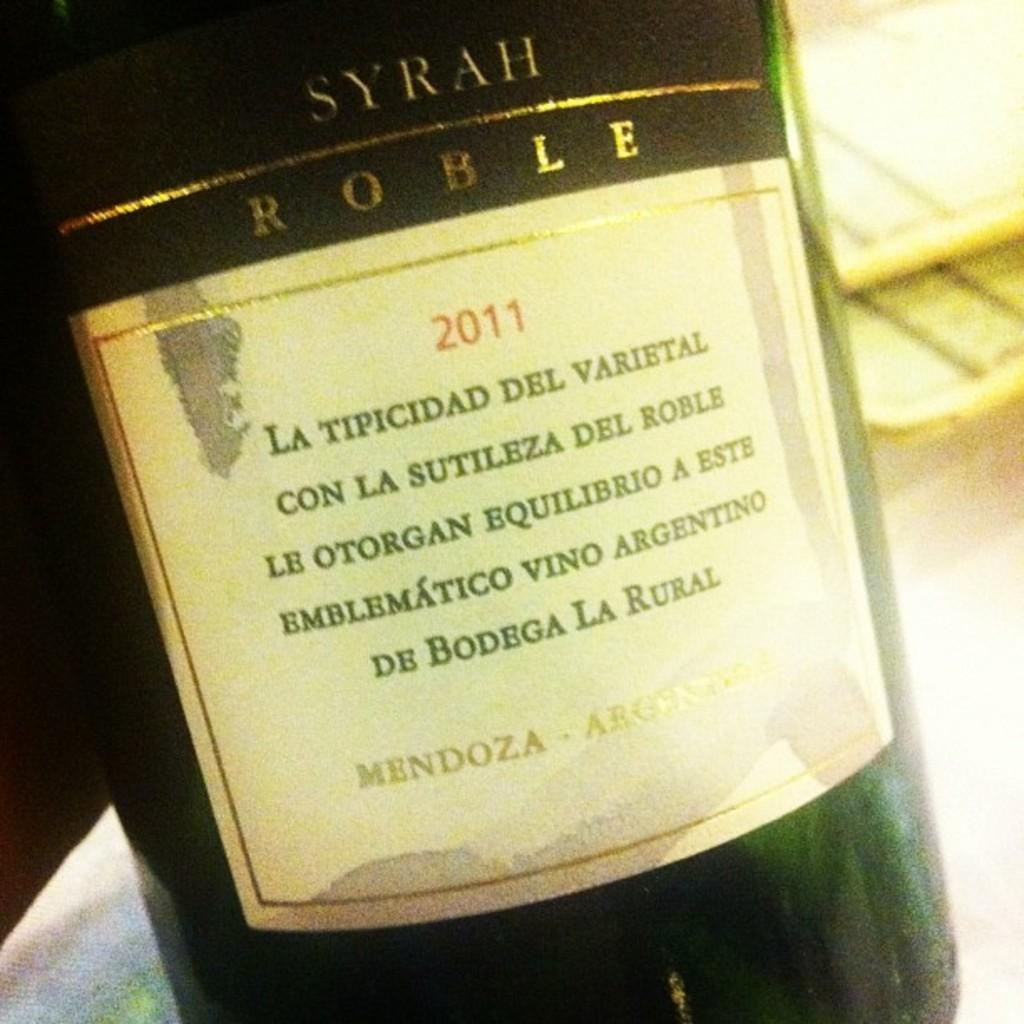<image>
Offer a succinct explanation of the picture presented. A bottle of Syrah Roble wine from 2011. 